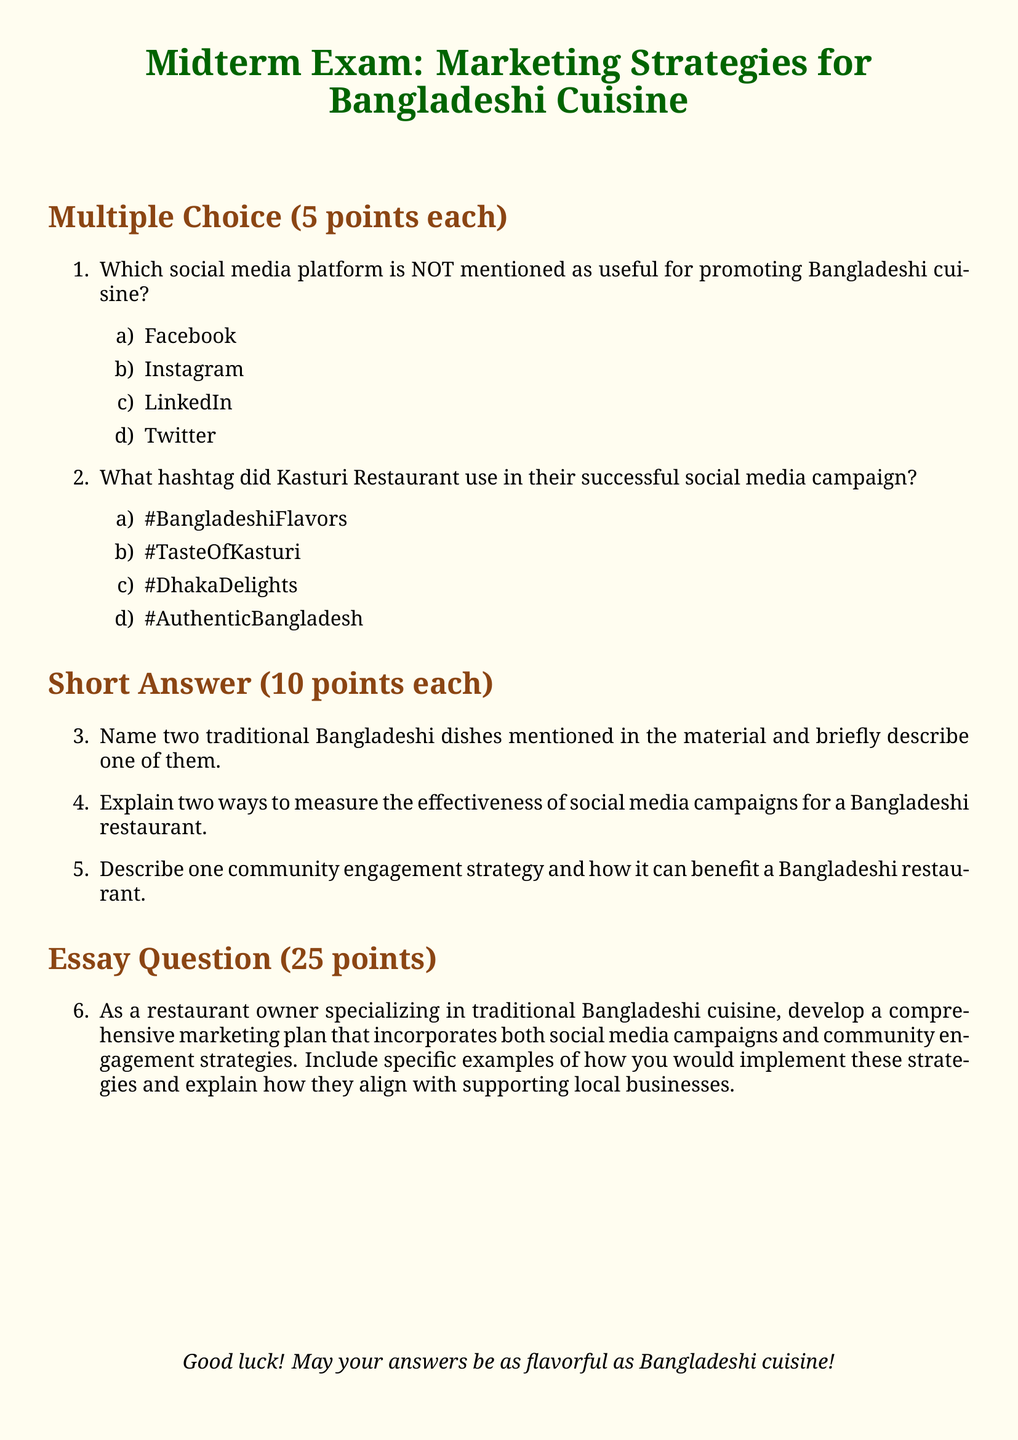What is the total number of points for multiple choice questions? The document states that each multiple choice question is worth 5 points, and there are 2 of them, leading to a total of 10 points.
Answer: 10 points What is the hashtag used by Kasturi Restaurant in their campaign? The document specifies that Kasturi Restaurant used the hashtag #TasteOfKasturi in their successful campaign.
Answer: #TasteOfKasturi How many traditional Bangladeshi dishes must be described in the short answer section? The short answer section requests the name of two traditional dishes, indicating that both should be mentioned.
Answer: Two dishes What is the point value for the essay question? The essay question is noted to be worth 25 points in the document.
Answer: 25 points What social media platform is mentioned as the least useful for promoting Bangladeshi cuisine? The document lists LinkedIn as the platform that is NOT mentioned for promoting Bangladeshi cuisine.
Answer: LinkedIn Identify one community engagement strategy relevant to the document. The document encourages the description of a community engagement strategy, though it does not specify one; it requires reasoning based on context.
Answer: Varies (context-dependent) What type of questions are primarily found in the midterm exam? The midterm exam mainly comprises multiple choice, short answer, and essay questions.
Answer: Multiple choice, short answer, essay 